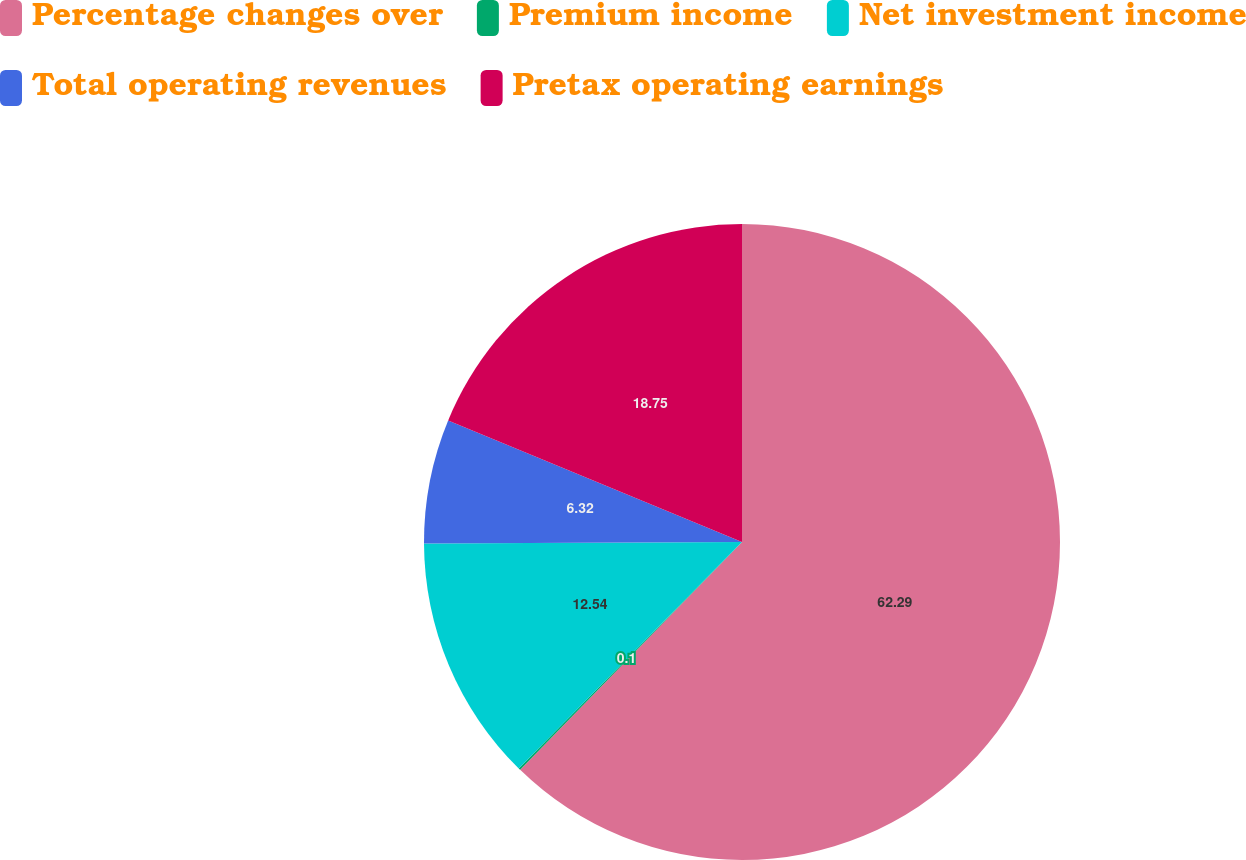Convert chart. <chart><loc_0><loc_0><loc_500><loc_500><pie_chart><fcel>Percentage changes over<fcel>Premium income<fcel>Net investment income<fcel>Total operating revenues<fcel>Pretax operating earnings<nl><fcel>62.3%<fcel>0.1%<fcel>12.54%<fcel>6.32%<fcel>18.76%<nl></chart> 